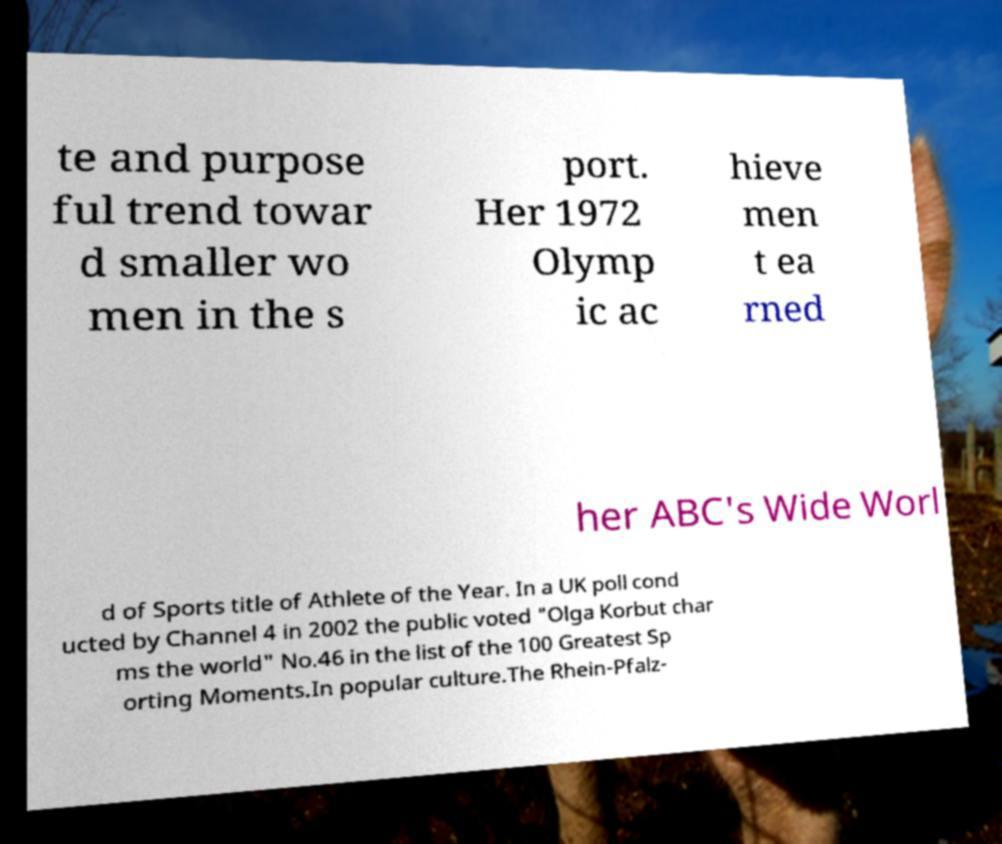Could you assist in decoding the text presented in this image and type it out clearly? te and purpose ful trend towar d smaller wo men in the s port. Her 1972 Olymp ic ac hieve men t ea rned her ABC's Wide Worl d of Sports title of Athlete of the Year. In a UK poll cond ucted by Channel 4 in 2002 the public voted "Olga Korbut char ms the world" No.46 in the list of the 100 Greatest Sp orting Moments.In popular culture.The Rhein-Pfalz- 